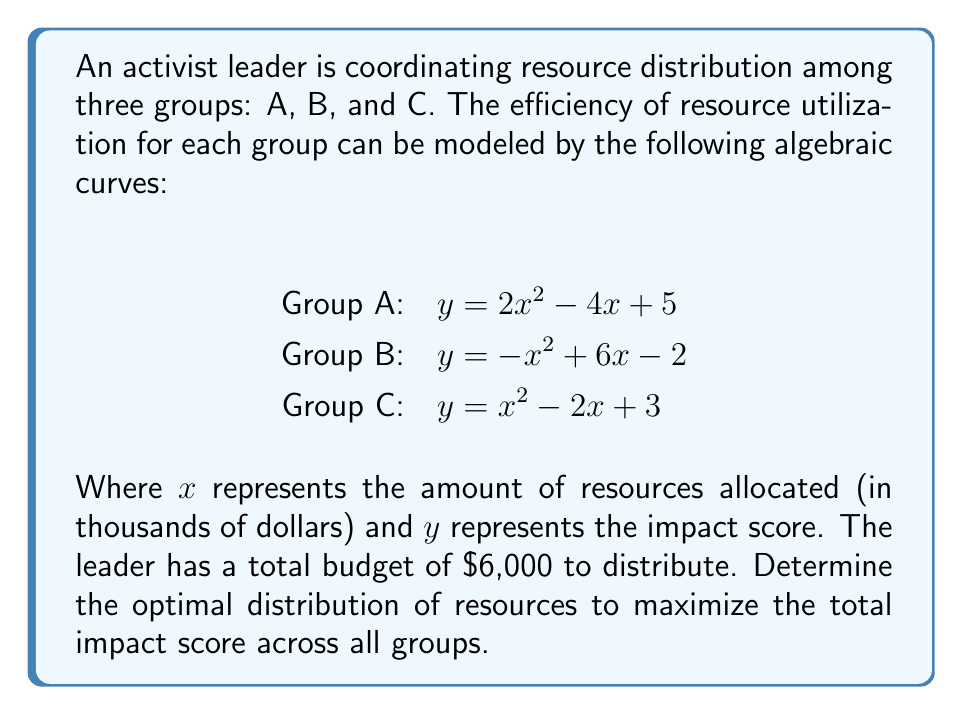Could you help me with this problem? 1) First, we need to find the maximum point for each curve within the domain [0, 6], as the total budget is $6,000.

2) For Group A: $y = 2x^2 - 4x + 5$
   The derivative is $y' = 4x - 4$
   Setting $y' = 0$: $4x - 4 = 0$, $x = 1$
   The maximum occurs at $x = 1$, $y = 2(1)^2 - 4(1) + 5 = 3$

3) For Group B: $y = -x^2 + 6x - 2$
   The derivative is $y' = -2x + 6$
   Setting $y' = 0$: $-2x + 6 = 0$, $x = 3$
   The maximum occurs at $x = 3$, $y = -(3)^2 + 6(3) - 2 = 7$

4) For Group C: $y = x^2 - 2x + 3$
   The derivative is $y' = 2x - 2$
   Setting $y' = 0$: $2x - 2 = 0$, $x = 1$
   The maximum occurs at $x = 1$, $y = (1)^2 - 2(1) + 3 = 2$

5) The optimal distribution should allocate resources to the points of maximum efficiency for each group. However, we need to ensure the total allocation doesn't exceed $6,000.

6) Optimal distribution:
   Group A: $1,000
   Group B: $3,000
   Group C: $1,000
   Total: $5,000 (which is within the budget)

7) The remaining $1,000 should be allocated to the group with the highest rate of increase at its maximum point, which is Group B.

8) Final distribution:
   Group A: $1,000 (Impact score: 3)
   Group B: $4,000 (Impact score: 6)
   Group C: $1,000 (Impact score: 2)

9) Total impact score: $3 + 6 + 2 = 11$
Answer: Group A: $1,000, Group B: $4,000, Group C: $1,000 